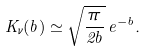Convert formula to latex. <formula><loc_0><loc_0><loc_500><loc_500>K _ { \nu } ( b ) \simeq \sqrt { \frac { \pi } { 2 b } } \, e ^ { - b } .</formula> 